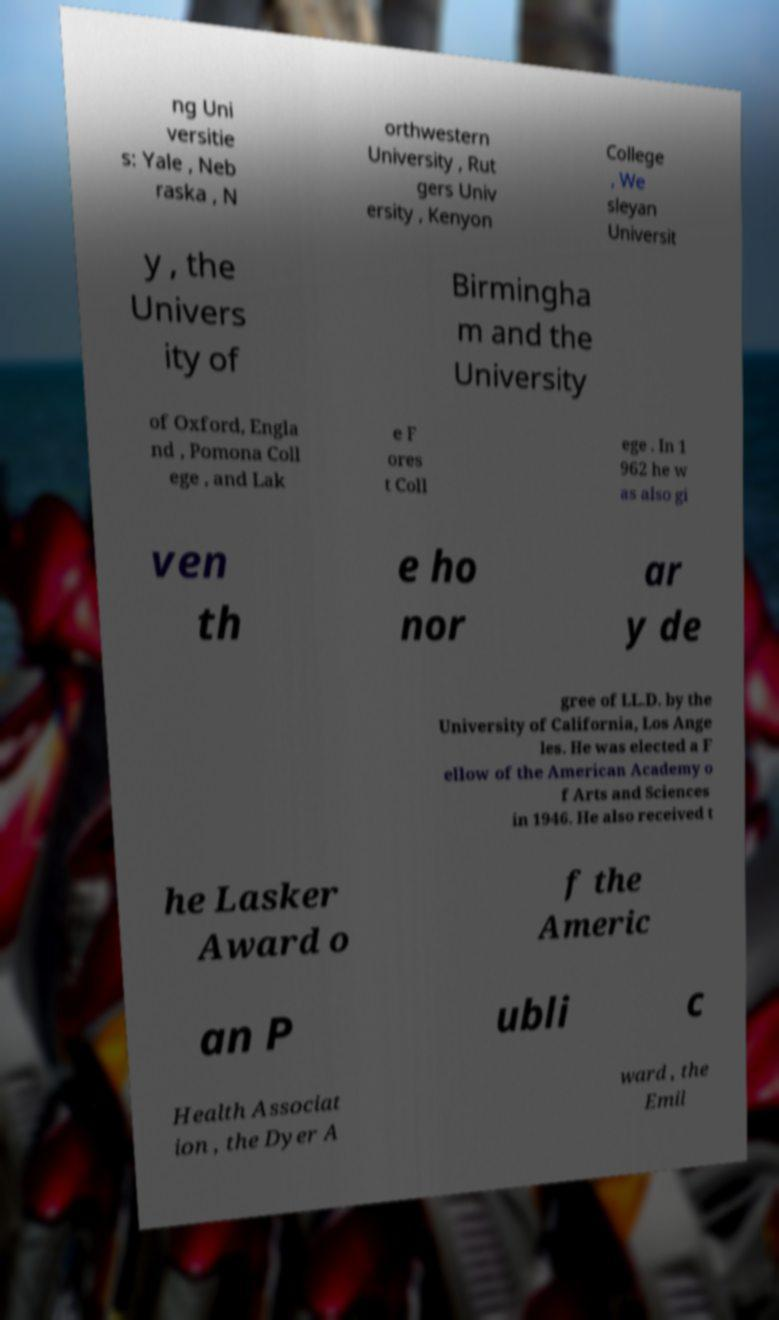Could you extract and type out the text from this image? ng Uni versitie s: Yale , Neb raska , N orthwestern University , Rut gers Univ ersity , Kenyon College , We sleyan Universit y , the Univers ity of Birmingha m and the University of Oxford, Engla nd , Pomona Coll ege , and Lak e F ores t Coll ege . In 1 962 he w as also gi ven th e ho nor ar y de gree of LL.D. by the University of California, Los Ange les. He was elected a F ellow of the American Academy o f Arts and Sciences in 1946. He also received t he Lasker Award o f the Americ an P ubli c Health Associat ion , the Dyer A ward , the Emil 